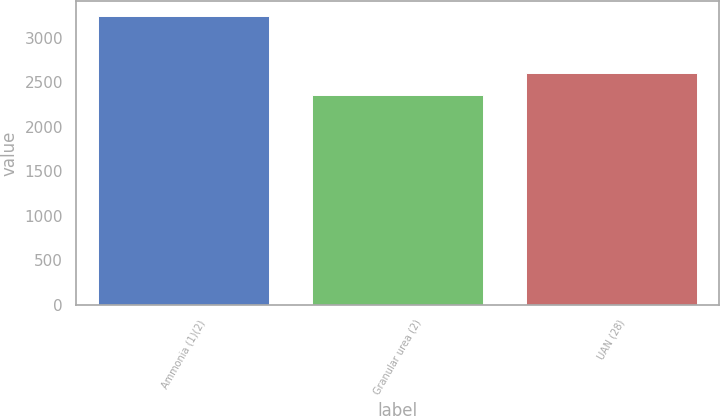<chart> <loc_0><loc_0><loc_500><loc_500><bar_chart><fcel>Ammonia (1)(2)<fcel>Granular urea (2)<fcel>UAN (28)<nl><fcel>3249<fcel>2355<fcel>2602<nl></chart> 